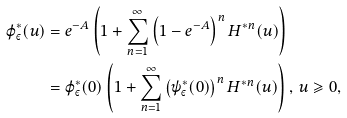<formula> <loc_0><loc_0><loc_500><loc_500>\varphi _ { \varepsilon } ^ { * } ( u ) & = e ^ { - A } \left ( 1 + \sum _ { n = 1 } ^ { \infty } \left ( 1 - e ^ { - A } \right ) ^ { n } H ^ { * n } ( u ) \right ) \\ & = \varphi _ { \varepsilon } ^ { * } ( 0 ) \left ( 1 + \sum _ { n = 1 } ^ { \infty } \left ( \psi _ { \varepsilon } ^ { * } ( 0 ) \right ) ^ { n } H ^ { * n } ( u ) \right ) , \, u \geqslant 0 ,</formula> 